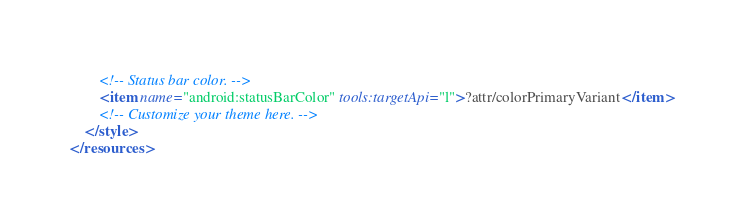<code> <loc_0><loc_0><loc_500><loc_500><_XML_>        <!-- Status bar color. -->
        <item name="android:statusBarColor" tools:targetApi="l">?attr/colorPrimaryVariant</item>
        <!-- Customize your theme here. -->
    </style>
</resources></code> 